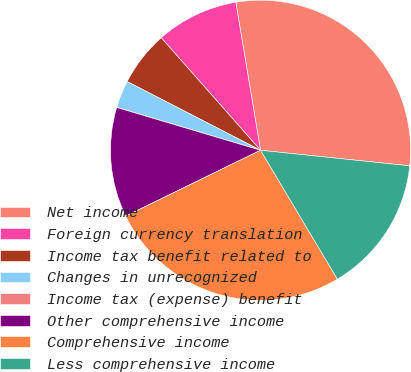Convert chart. <chart><loc_0><loc_0><loc_500><loc_500><pie_chart><fcel>Net income<fcel>Foreign currency translation<fcel>Income tax benefit related to<fcel>Changes in unrecognized<fcel>Income tax (expense) benefit<fcel>Other comprehensive income<fcel>Comprehensive income<fcel>Less comprehensive income<nl><fcel>29.29%<fcel>8.87%<fcel>5.92%<fcel>2.96%<fcel>0.01%<fcel>11.83%<fcel>26.33%<fcel>14.79%<nl></chart> 